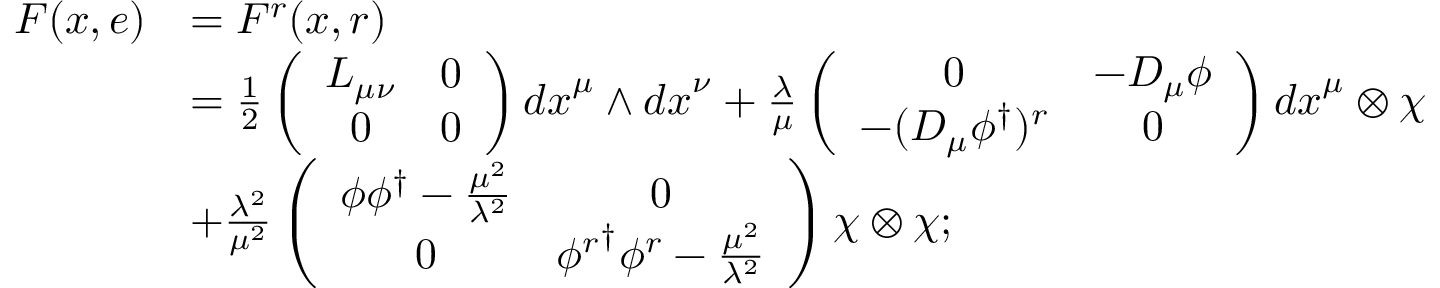Convert formula to latex. <formula><loc_0><loc_0><loc_500><loc_500>\begin{array} { c l } { F ( x , e ) } & { { = F ^ { r } ( x , r ) } } & { { = \frac { 1 } { 2 } \left ( \begin{array} { c c } { { L _ { \mu \nu } } } & { 0 } \\ { 0 } & { 0 } \end{array} \right ) { d x } ^ { \mu } \wedge { d x } ^ { \nu } + \frac { \lambda } { \mu } \left ( \begin{array} { c c } { 0 } & { { { - D _ { \mu } \phi } } } \\ { { - ( D _ { \mu } \phi ^ { \dag } ) ^ { r } } } & { 0 } \end{array} \right ) { d x } ^ { \mu } \otimes { \chi } } } & { { + \frac { { \lambda } ^ { 2 } } { { \mu } ^ { 2 } } \left ( \begin{array} { c c } { { { \phi { \phi } ^ { \dag } - \frac { { \mu } ^ { 2 } } { \lambda ^ { 2 } } } } } & { 0 } \\ { 0 } & { { { \phi ^ { r } } ^ { \dag } { \phi } ^ { r } - \frac { \mu ^ { 2 } } { \lambda ^ { 2 } } } } \end{array} \right ) { \chi } \otimes { \chi } ; } } \end{array}</formula> 